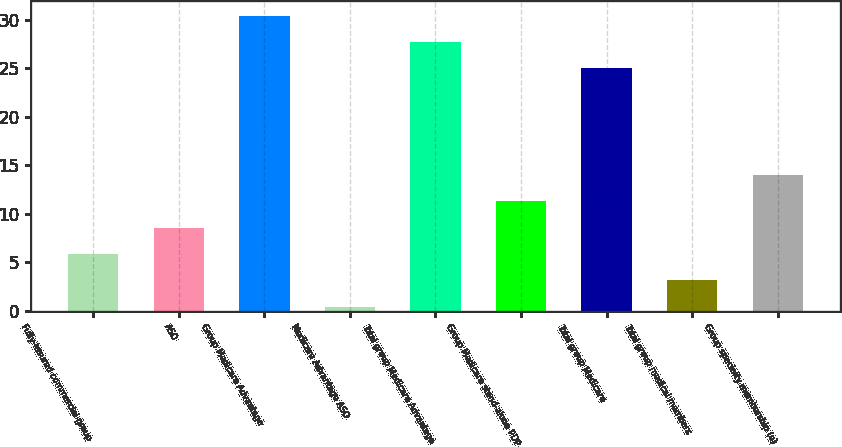<chart> <loc_0><loc_0><loc_500><loc_500><bar_chart><fcel>Fully-insured commercial group<fcel>ASO<fcel>Group Medicare Advantage<fcel>Medicare Advantage ASO<fcel>Total group Medicare Advantage<fcel>Group Medicare stand-alone PDP<fcel>Total group Medicare<fcel>Total group medical members<fcel>Group specialty membership (a)<nl><fcel>5.84<fcel>8.56<fcel>30.44<fcel>0.4<fcel>27.72<fcel>11.28<fcel>25<fcel>3.12<fcel>14<nl></chart> 